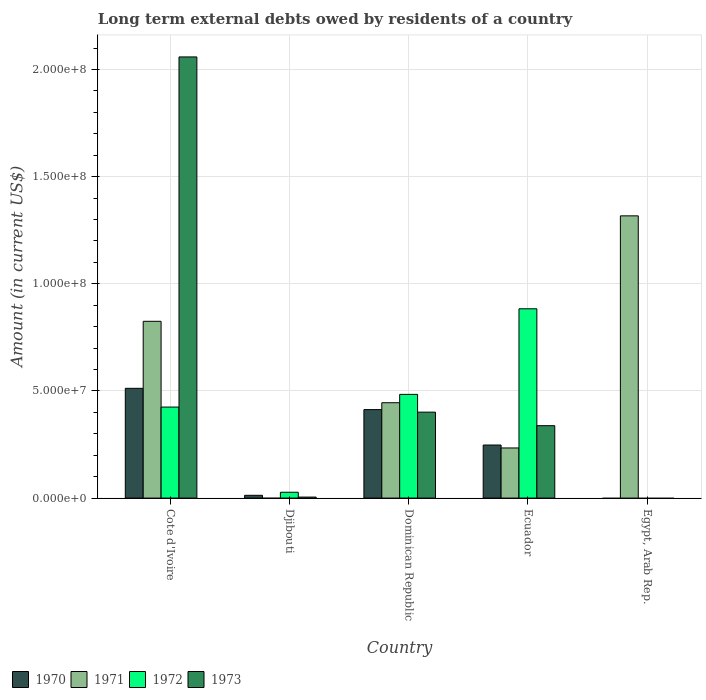Are the number of bars on each tick of the X-axis equal?
Keep it short and to the point. No. How many bars are there on the 1st tick from the left?
Your answer should be very brief. 4. How many bars are there on the 2nd tick from the right?
Provide a succinct answer. 4. What is the label of the 5th group of bars from the left?
Give a very brief answer. Egypt, Arab Rep. In how many cases, is the number of bars for a given country not equal to the number of legend labels?
Provide a succinct answer. 2. What is the amount of long-term external debts owed by residents in 1970 in Djibouti?
Your answer should be very brief. 1.30e+06. Across all countries, what is the maximum amount of long-term external debts owed by residents in 1973?
Your response must be concise. 2.06e+08. Across all countries, what is the minimum amount of long-term external debts owed by residents in 1970?
Give a very brief answer. 0. In which country was the amount of long-term external debts owed by residents in 1973 maximum?
Offer a terse response. Cote d'Ivoire. What is the total amount of long-term external debts owed by residents in 1971 in the graph?
Ensure brevity in your answer.  2.82e+08. What is the difference between the amount of long-term external debts owed by residents in 1972 in Djibouti and that in Ecuador?
Give a very brief answer. -8.56e+07. What is the difference between the amount of long-term external debts owed by residents in 1971 in Egypt, Arab Rep. and the amount of long-term external debts owed by residents in 1973 in Cote d'Ivoire?
Ensure brevity in your answer.  -7.42e+07. What is the average amount of long-term external debts owed by residents in 1973 per country?
Give a very brief answer. 5.60e+07. What is the difference between the amount of long-term external debts owed by residents of/in 1971 and amount of long-term external debts owed by residents of/in 1973 in Dominican Republic?
Offer a terse response. 4.39e+06. In how many countries, is the amount of long-term external debts owed by residents in 1970 greater than 80000000 US$?
Offer a terse response. 0. What is the ratio of the amount of long-term external debts owed by residents in 1970 in Djibouti to that in Ecuador?
Your answer should be compact. 0.05. Is the amount of long-term external debts owed by residents in 1973 in Cote d'Ivoire less than that in Ecuador?
Provide a short and direct response. No. Is the difference between the amount of long-term external debts owed by residents in 1971 in Cote d'Ivoire and Ecuador greater than the difference between the amount of long-term external debts owed by residents in 1973 in Cote d'Ivoire and Ecuador?
Keep it short and to the point. No. What is the difference between the highest and the second highest amount of long-term external debts owed by residents in 1972?
Provide a short and direct response. 4.59e+07. What is the difference between the highest and the lowest amount of long-term external debts owed by residents in 1971?
Offer a very short reply. 1.32e+08. In how many countries, is the amount of long-term external debts owed by residents in 1973 greater than the average amount of long-term external debts owed by residents in 1973 taken over all countries?
Your answer should be very brief. 1. Is it the case that in every country, the sum of the amount of long-term external debts owed by residents in 1972 and amount of long-term external debts owed by residents in 1971 is greater than the sum of amount of long-term external debts owed by residents in 1970 and amount of long-term external debts owed by residents in 1973?
Keep it short and to the point. No. Are all the bars in the graph horizontal?
Give a very brief answer. No. Does the graph contain grids?
Provide a short and direct response. Yes. Where does the legend appear in the graph?
Make the answer very short. Bottom left. How many legend labels are there?
Make the answer very short. 4. How are the legend labels stacked?
Offer a very short reply. Horizontal. What is the title of the graph?
Offer a very short reply. Long term external debts owed by residents of a country. Does "1982" appear as one of the legend labels in the graph?
Give a very brief answer. No. What is the label or title of the X-axis?
Ensure brevity in your answer.  Country. What is the Amount (in current US$) of 1970 in Cote d'Ivoire?
Offer a terse response. 5.12e+07. What is the Amount (in current US$) of 1971 in Cote d'Ivoire?
Provide a succinct answer. 8.25e+07. What is the Amount (in current US$) in 1972 in Cote d'Ivoire?
Your answer should be very brief. 4.25e+07. What is the Amount (in current US$) in 1973 in Cote d'Ivoire?
Provide a succinct answer. 2.06e+08. What is the Amount (in current US$) of 1970 in Djibouti?
Your response must be concise. 1.30e+06. What is the Amount (in current US$) of 1971 in Djibouti?
Give a very brief answer. 0. What is the Amount (in current US$) of 1972 in Djibouti?
Your answer should be compact. 2.72e+06. What is the Amount (in current US$) of 1973 in Djibouti?
Offer a terse response. 4.68e+05. What is the Amount (in current US$) of 1970 in Dominican Republic?
Provide a succinct answer. 4.13e+07. What is the Amount (in current US$) in 1971 in Dominican Republic?
Keep it short and to the point. 4.45e+07. What is the Amount (in current US$) of 1972 in Dominican Republic?
Provide a succinct answer. 4.84e+07. What is the Amount (in current US$) in 1973 in Dominican Republic?
Offer a terse response. 4.01e+07. What is the Amount (in current US$) in 1970 in Ecuador?
Make the answer very short. 2.48e+07. What is the Amount (in current US$) of 1971 in Ecuador?
Your response must be concise. 2.34e+07. What is the Amount (in current US$) in 1972 in Ecuador?
Your answer should be very brief. 8.83e+07. What is the Amount (in current US$) in 1973 in Ecuador?
Ensure brevity in your answer.  3.38e+07. What is the Amount (in current US$) in 1971 in Egypt, Arab Rep.?
Ensure brevity in your answer.  1.32e+08. What is the Amount (in current US$) in 1972 in Egypt, Arab Rep.?
Keep it short and to the point. 0. Across all countries, what is the maximum Amount (in current US$) of 1970?
Offer a terse response. 5.12e+07. Across all countries, what is the maximum Amount (in current US$) of 1971?
Provide a succinct answer. 1.32e+08. Across all countries, what is the maximum Amount (in current US$) in 1972?
Your answer should be very brief. 8.83e+07. Across all countries, what is the maximum Amount (in current US$) of 1973?
Your answer should be compact. 2.06e+08. Across all countries, what is the minimum Amount (in current US$) in 1972?
Your response must be concise. 0. Across all countries, what is the minimum Amount (in current US$) of 1973?
Provide a short and direct response. 0. What is the total Amount (in current US$) in 1970 in the graph?
Provide a short and direct response. 1.19e+08. What is the total Amount (in current US$) in 1971 in the graph?
Ensure brevity in your answer.  2.82e+08. What is the total Amount (in current US$) of 1972 in the graph?
Offer a very short reply. 1.82e+08. What is the total Amount (in current US$) of 1973 in the graph?
Provide a short and direct response. 2.80e+08. What is the difference between the Amount (in current US$) of 1970 in Cote d'Ivoire and that in Djibouti?
Provide a short and direct response. 4.99e+07. What is the difference between the Amount (in current US$) in 1972 in Cote d'Ivoire and that in Djibouti?
Offer a very short reply. 3.98e+07. What is the difference between the Amount (in current US$) in 1973 in Cote d'Ivoire and that in Djibouti?
Offer a very short reply. 2.05e+08. What is the difference between the Amount (in current US$) in 1970 in Cote d'Ivoire and that in Dominican Republic?
Provide a succinct answer. 9.93e+06. What is the difference between the Amount (in current US$) in 1971 in Cote d'Ivoire and that in Dominican Republic?
Give a very brief answer. 3.80e+07. What is the difference between the Amount (in current US$) in 1972 in Cote d'Ivoire and that in Dominican Republic?
Offer a very short reply. -5.92e+06. What is the difference between the Amount (in current US$) of 1973 in Cote d'Ivoire and that in Dominican Republic?
Your answer should be compact. 1.66e+08. What is the difference between the Amount (in current US$) of 1970 in Cote d'Ivoire and that in Ecuador?
Ensure brevity in your answer.  2.65e+07. What is the difference between the Amount (in current US$) in 1971 in Cote d'Ivoire and that in Ecuador?
Offer a very short reply. 5.91e+07. What is the difference between the Amount (in current US$) in 1972 in Cote d'Ivoire and that in Ecuador?
Keep it short and to the point. -4.59e+07. What is the difference between the Amount (in current US$) in 1973 in Cote d'Ivoire and that in Ecuador?
Keep it short and to the point. 1.72e+08. What is the difference between the Amount (in current US$) in 1971 in Cote d'Ivoire and that in Egypt, Arab Rep.?
Provide a succinct answer. -4.92e+07. What is the difference between the Amount (in current US$) in 1970 in Djibouti and that in Dominican Republic?
Your response must be concise. -4.00e+07. What is the difference between the Amount (in current US$) in 1972 in Djibouti and that in Dominican Republic?
Your answer should be compact. -4.57e+07. What is the difference between the Amount (in current US$) of 1973 in Djibouti and that in Dominican Republic?
Give a very brief answer. -3.96e+07. What is the difference between the Amount (in current US$) in 1970 in Djibouti and that in Ecuador?
Provide a succinct answer. -2.35e+07. What is the difference between the Amount (in current US$) of 1972 in Djibouti and that in Ecuador?
Keep it short and to the point. -8.56e+07. What is the difference between the Amount (in current US$) in 1973 in Djibouti and that in Ecuador?
Ensure brevity in your answer.  -3.33e+07. What is the difference between the Amount (in current US$) in 1970 in Dominican Republic and that in Ecuador?
Provide a short and direct response. 1.65e+07. What is the difference between the Amount (in current US$) of 1971 in Dominican Republic and that in Ecuador?
Your answer should be very brief. 2.11e+07. What is the difference between the Amount (in current US$) in 1972 in Dominican Republic and that in Ecuador?
Your answer should be very brief. -3.99e+07. What is the difference between the Amount (in current US$) in 1973 in Dominican Republic and that in Ecuador?
Make the answer very short. 6.31e+06. What is the difference between the Amount (in current US$) of 1971 in Dominican Republic and that in Egypt, Arab Rep.?
Offer a terse response. -8.72e+07. What is the difference between the Amount (in current US$) in 1971 in Ecuador and that in Egypt, Arab Rep.?
Your answer should be compact. -1.08e+08. What is the difference between the Amount (in current US$) of 1970 in Cote d'Ivoire and the Amount (in current US$) of 1972 in Djibouti?
Give a very brief answer. 4.85e+07. What is the difference between the Amount (in current US$) in 1970 in Cote d'Ivoire and the Amount (in current US$) in 1973 in Djibouti?
Provide a short and direct response. 5.08e+07. What is the difference between the Amount (in current US$) in 1971 in Cote d'Ivoire and the Amount (in current US$) in 1972 in Djibouti?
Offer a terse response. 7.98e+07. What is the difference between the Amount (in current US$) of 1971 in Cote d'Ivoire and the Amount (in current US$) of 1973 in Djibouti?
Offer a terse response. 8.20e+07. What is the difference between the Amount (in current US$) in 1972 in Cote d'Ivoire and the Amount (in current US$) in 1973 in Djibouti?
Ensure brevity in your answer.  4.20e+07. What is the difference between the Amount (in current US$) of 1970 in Cote d'Ivoire and the Amount (in current US$) of 1971 in Dominican Republic?
Offer a terse response. 6.73e+06. What is the difference between the Amount (in current US$) in 1970 in Cote d'Ivoire and the Amount (in current US$) in 1972 in Dominican Republic?
Give a very brief answer. 2.83e+06. What is the difference between the Amount (in current US$) in 1970 in Cote d'Ivoire and the Amount (in current US$) in 1973 in Dominican Republic?
Provide a succinct answer. 1.11e+07. What is the difference between the Amount (in current US$) in 1971 in Cote d'Ivoire and the Amount (in current US$) in 1972 in Dominican Republic?
Make the answer very short. 3.41e+07. What is the difference between the Amount (in current US$) in 1971 in Cote d'Ivoire and the Amount (in current US$) in 1973 in Dominican Republic?
Your answer should be compact. 4.24e+07. What is the difference between the Amount (in current US$) in 1972 in Cote d'Ivoire and the Amount (in current US$) in 1973 in Dominican Republic?
Your answer should be compact. 2.37e+06. What is the difference between the Amount (in current US$) of 1970 in Cote d'Ivoire and the Amount (in current US$) of 1971 in Ecuador?
Give a very brief answer. 2.78e+07. What is the difference between the Amount (in current US$) of 1970 in Cote d'Ivoire and the Amount (in current US$) of 1972 in Ecuador?
Provide a succinct answer. -3.71e+07. What is the difference between the Amount (in current US$) of 1970 in Cote d'Ivoire and the Amount (in current US$) of 1973 in Ecuador?
Your answer should be compact. 1.74e+07. What is the difference between the Amount (in current US$) in 1971 in Cote d'Ivoire and the Amount (in current US$) in 1972 in Ecuador?
Give a very brief answer. -5.84e+06. What is the difference between the Amount (in current US$) in 1971 in Cote d'Ivoire and the Amount (in current US$) in 1973 in Ecuador?
Provide a short and direct response. 4.87e+07. What is the difference between the Amount (in current US$) in 1972 in Cote d'Ivoire and the Amount (in current US$) in 1973 in Ecuador?
Your response must be concise. 8.68e+06. What is the difference between the Amount (in current US$) in 1970 in Cote d'Ivoire and the Amount (in current US$) in 1971 in Egypt, Arab Rep.?
Make the answer very short. -8.05e+07. What is the difference between the Amount (in current US$) of 1970 in Djibouti and the Amount (in current US$) of 1971 in Dominican Republic?
Provide a short and direct response. -4.32e+07. What is the difference between the Amount (in current US$) of 1970 in Djibouti and the Amount (in current US$) of 1972 in Dominican Republic?
Make the answer very short. -4.71e+07. What is the difference between the Amount (in current US$) in 1970 in Djibouti and the Amount (in current US$) in 1973 in Dominican Republic?
Your answer should be compact. -3.88e+07. What is the difference between the Amount (in current US$) in 1972 in Djibouti and the Amount (in current US$) in 1973 in Dominican Republic?
Make the answer very short. -3.74e+07. What is the difference between the Amount (in current US$) of 1970 in Djibouti and the Amount (in current US$) of 1971 in Ecuador?
Your answer should be compact. -2.21e+07. What is the difference between the Amount (in current US$) of 1970 in Djibouti and the Amount (in current US$) of 1972 in Ecuador?
Ensure brevity in your answer.  -8.70e+07. What is the difference between the Amount (in current US$) in 1970 in Djibouti and the Amount (in current US$) in 1973 in Ecuador?
Keep it short and to the point. -3.25e+07. What is the difference between the Amount (in current US$) of 1972 in Djibouti and the Amount (in current US$) of 1973 in Ecuador?
Your answer should be compact. -3.11e+07. What is the difference between the Amount (in current US$) of 1970 in Djibouti and the Amount (in current US$) of 1971 in Egypt, Arab Rep.?
Your answer should be very brief. -1.30e+08. What is the difference between the Amount (in current US$) of 1970 in Dominican Republic and the Amount (in current US$) of 1971 in Ecuador?
Provide a succinct answer. 1.79e+07. What is the difference between the Amount (in current US$) of 1970 in Dominican Republic and the Amount (in current US$) of 1972 in Ecuador?
Provide a succinct answer. -4.70e+07. What is the difference between the Amount (in current US$) in 1970 in Dominican Republic and the Amount (in current US$) in 1973 in Ecuador?
Your answer should be very brief. 7.50e+06. What is the difference between the Amount (in current US$) of 1971 in Dominican Republic and the Amount (in current US$) of 1972 in Ecuador?
Your response must be concise. -4.38e+07. What is the difference between the Amount (in current US$) in 1971 in Dominican Republic and the Amount (in current US$) in 1973 in Ecuador?
Give a very brief answer. 1.07e+07. What is the difference between the Amount (in current US$) in 1972 in Dominican Republic and the Amount (in current US$) in 1973 in Ecuador?
Offer a terse response. 1.46e+07. What is the difference between the Amount (in current US$) in 1970 in Dominican Republic and the Amount (in current US$) in 1971 in Egypt, Arab Rep.?
Make the answer very short. -9.04e+07. What is the difference between the Amount (in current US$) of 1970 in Ecuador and the Amount (in current US$) of 1971 in Egypt, Arab Rep.?
Offer a terse response. -1.07e+08. What is the average Amount (in current US$) of 1970 per country?
Provide a succinct answer. 2.37e+07. What is the average Amount (in current US$) of 1971 per country?
Give a very brief answer. 5.64e+07. What is the average Amount (in current US$) in 1972 per country?
Give a very brief answer. 3.64e+07. What is the average Amount (in current US$) of 1973 per country?
Ensure brevity in your answer.  5.60e+07. What is the difference between the Amount (in current US$) of 1970 and Amount (in current US$) of 1971 in Cote d'Ivoire?
Offer a very short reply. -3.13e+07. What is the difference between the Amount (in current US$) in 1970 and Amount (in current US$) in 1972 in Cote d'Ivoire?
Your answer should be compact. 8.75e+06. What is the difference between the Amount (in current US$) of 1970 and Amount (in current US$) of 1973 in Cote d'Ivoire?
Provide a succinct answer. -1.55e+08. What is the difference between the Amount (in current US$) of 1971 and Amount (in current US$) of 1972 in Cote d'Ivoire?
Keep it short and to the point. 4.00e+07. What is the difference between the Amount (in current US$) of 1971 and Amount (in current US$) of 1973 in Cote d'Ivoire?
Give a very brief answer. -1.23e+08. What is the difference between the Amount (in current US$) of 1972 and Amount (in current US$) of 1973 in Cote d'Ivoire?
Your response must be concise. -1.63e+08. What is the difference between the Amount (in current US$) in 1970 and Amount (in current US$) in 1972 in Djibouti?
Your answer should be compact. -1.42e+06. What is the difference between the Amount (in current US$) of 1970 and Amount (in current US$) of 1973 in Djibouti?
Provide a short and direct response. 8.32e+05. What is the difference between the Amount (in current US$) in 1972 and Amount (in current US$) in 1973 in Djibouti?
Ensure brevity in your answer.  2.26e+06. What is the difference between the Amount (in current US$) in 1970 and Amount (in current US$) in 1971 in Dominican Republic?
Your answer should be very brief. -3.21e+06. What is the difference between the Amount (in current US$) in 1970 and Amount (in current US$) in 1972 in Dominican Republic?
Offer a terse response. -7.11e+06. What is the difference between the Amount (in current US$) of 1970 and Amount (in current US$) of 1973 in Dominican Republic?
Provide a short and direct response. 1.19e+06. What is the difference between the Amount (in current US$) of 1971 and Amount (in current US$) of 1972 in Dominican Republic?
Provide a short and direct response. -3.90e+06. What is the difference between the Amount (in current US$) of 1971 and Amount (in current US$) of 1973 in Dominican Republic?
Keep it short and to the point. 4.39e+06. What is the difference between the Amount (in current US$) in 1972 and Amount (in current US$) in 1973 in Dominican Republic?
Give a very brief answer. 8.29e+06. What is the difference between the Amount (in current US$) in 1970 and Amount (in current US$) in 1971 in Ecuador?
Provide a short and direct response. 1.37e+06. What is the difference between the Amount (in current US$) of 1970 and Amount (in current US$) of 1972 in Ecuador?
Your answer should be very brief. -6.36e+07. What is the difference between the Amount (in current US$) of 1970 and Amount (in current US$) of 1973 in Ecuador?
Provide a succinct answer. -9.03e+06. What is the difference between the Amount (in current US$) in 1971 and Amount (in current US$) in 1972 in Ecuador?
Make the answer very short. -6.49e+07. What is the difference between the Amount (in current US$) in 1971 and Amount (in current US$) in 1973 in Ecuador?
Make the answer very short. -1.04e+07. What is the difference between the Amount (in current US$) in 1972 and Amount (in current US$) in 1973 in Ecuador?
Make the answer very short. 5.45e+07. What is the ratio of the Amount (in current US$) in 1970 in Cote d'Ivoire to that in Djibouti?
Provide a short and direct response. 39.4. What is the ratio of the Amount (in current US$) in 1972 in Cote d'Ivoire to that in Djibouti?
Your response must be concise. 15.6. What is the ratio of the Amount (in current US$) of 1973 in Cote d'Ivoire to that in Djibouti?
Offer a terse response. 439.86. What is the ratio of the Amount (in current US$) in 1970 in Cote d'Ivoire to that in Dominican Republic?
Your response must be concise. 1.24. What is the ratio of the Amount (in current US$) of 1971 in Cote d'Ivoire to that in Dominican Republic?
Offer a terse response. 1.85. What is the ratio of the Amount (in current US$) in 1972 in Cote d'Ivoire to that in Dominican Republic?
Provide a short and direct response. 0.88. What is the ratio of the Amount (in current US$) in 1973 in Cote d'Ivoire to that in Dominican Republic?
Offer a terse response. 5.13. What is the ratio of the Amount (in current US$) of 1970 in Cote d'Ivoire to that in Ecuador?
Provide a short and direct response. 2.07. What is the ratio of the Amount (in current US$) of 1971 in Cote d'Ivoire to that in Ecuador?
Offer a very short reply. 3.53. What is the ratio of the Amount (in current US$) in 1972 in Cote d'Ivoire to that in Ecuador?
Offer a very short reply. 0.48. What is the ratio of the Amount (in current US$) in 1973 in Cote d'Ivoire to that in Ecuador?
Ensure brevity in your answer.  6.09. What is the ratio of the Amount (in current US$) in 1971 in Cote d'Ivoire to that in Egypt, Arab Rep.?
Provide a short and direct response. 0.63. What is the ratio of the Amount (in current US$) of 1970 in Djibouti to that in Dominican Republic?
Provide a short and direct response. 0.03. What is the ratio of the Amount (in current US$) of 1972 in Djibouti to that in Dominican Republic?
Offer a terse response. 0.06. What is the ratio of the Amount (in current US$) of 1973 in Djibouti to that in Dominican Republic?
Your response must be concise. 0.01. What is the ratio of the Amount (in current US$) of 1970 in Djibouti to that in Ecuador?
Your answer should be compact. 0.05. What is the ratio of the Amount (in current US$) of 1972 in Djibouti to that in Ecuador?
Offer a terse response. 0.03. What is the ratio of the Amount (in current US$) in 1973 in Djibouti to that in Ecuador?
Your answer should be very brief. 0.01. What is the ratio of the Amount (in current US$) of 1970 in Dominican Republic to that in Ecuador?
Your response must be concise. 1.67. What is the ratio of the Amount (in current US$) in 1971 in Dominican Republic to that in Ecuador?
Ensure brevity in your answer.  1.9. What is the ratio of the Amount (in current US$) in 1972 in Dominican Republic to that in Ecuador?
Make the answer very short. 0.55. What is the ratio of the Amount (in current US$) of 1973 in Dominican Republic to that in Ecuador?
Give a very brief answer. 1.19. What is the ratio of the Amount (in current US$) in 1971 in Dominican Republic to that in Egypt, Arab Rep.?
Give a very brief answer. 0.34. What is the ratio of the Amount (in current US$) of 1971 in Ecuador to that in Egypt, Arab Rep.?
Offer a terse response. 0.18. What is the difference between the highest and the second highest Amount (in current US$) in 1970?
Make the answer very short. 9.93e+06. What is the difference between the highest and the second highest Amount (in current US$) in 1971?
Your response must be concise. 4.92e+07. What is the difference between the highest and the second highest Amount (in current US$) in 1972?
Keep it short and to the point. 3.99e+07. What is the difference between the highest and the second highest Amount (in current US$) in 1973?
Ensure brevity in your answer.  1.66e+08. What is the difference between the highest and the lowest Amount (in current US$) of 1970?
Your response must be concise. 5.12e+07. What is the difference between the highest and the lowest Amount (in current US$) in 1971?
Your response must be concise. 1.32e+08. What is the difference between the highest and the lowest Amount (in current US$) in 1972?
Your answer should be compact. 8.83e+07. What is the difference between the highest and the lowest Amount (in current US$) in 1973?
Your answer should be very brief. 2.06e+08. 